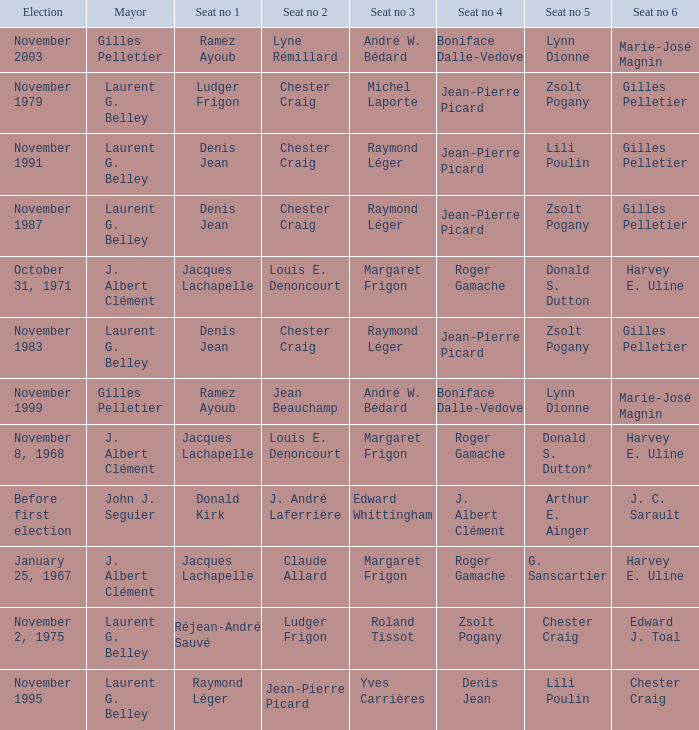Which election had seat no 1 filled by jacques lachapelle but seat no 5 was filled by g. sanscartier January 25, 1967. 